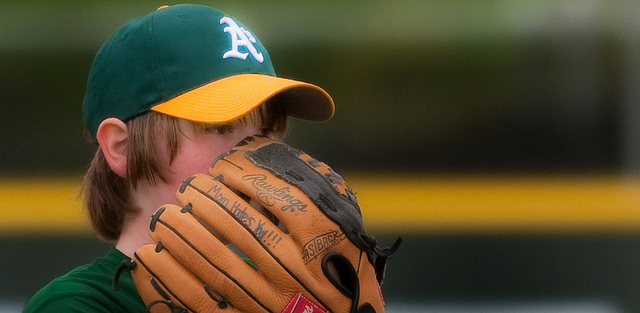Identify the text displayed in this image. A's Rawbings Mom SIBRC Hotes You 